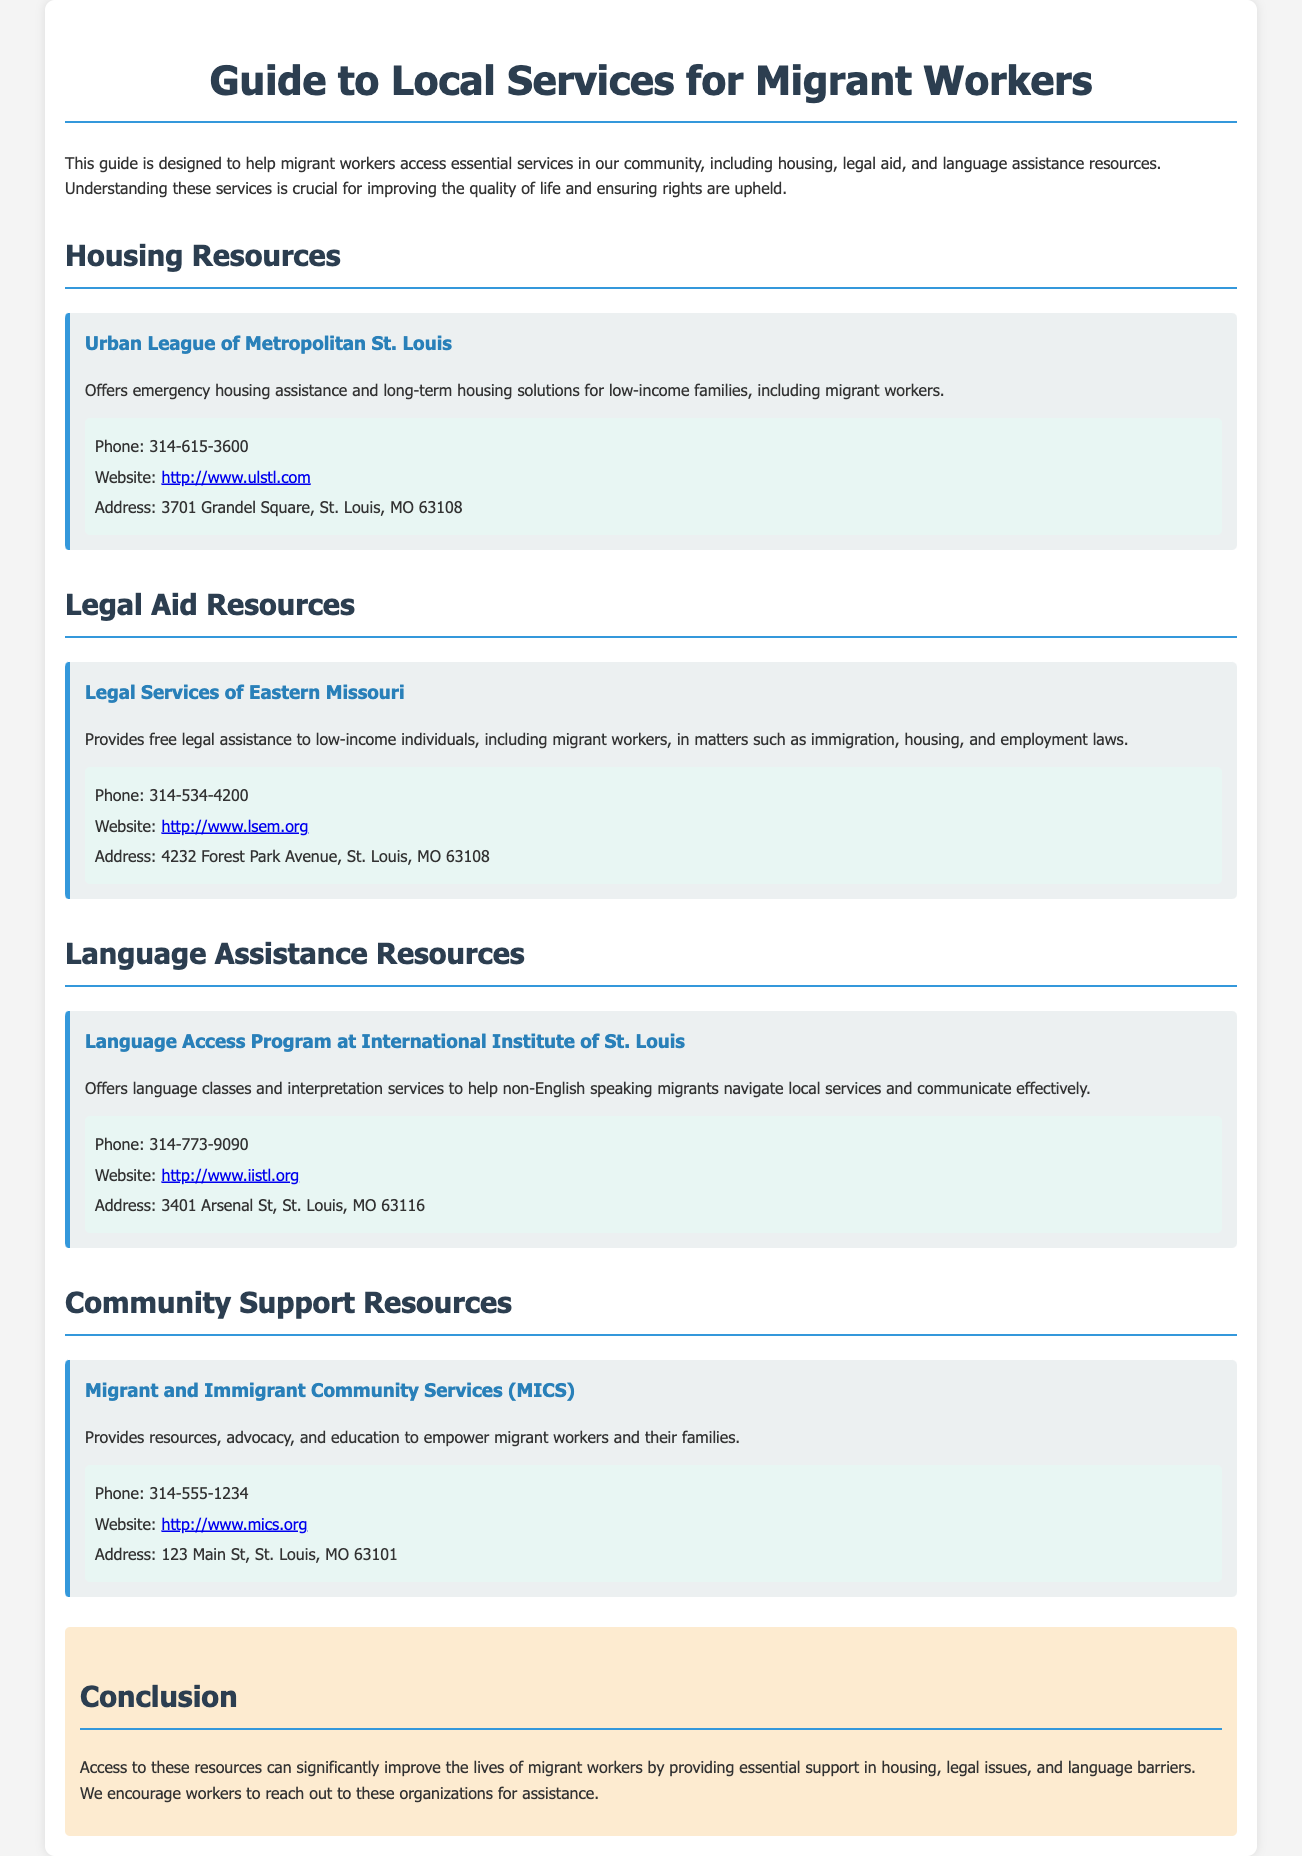What organization offers emergency housing assistance? The document lists the Urban League of Metropolitan St. Louis as providing emergency housing assistance for low-income families, including migrant workers.
Answer: Urban League of Metropolitan St. Louis What is the phone number for Legal Services of Eastern Missouri? The document provides the contact information for Legal Services of Eastern Missouri, specifically their phone number.
Answer: 314-534-4200 Which program provides language classes for migrants? The Language Access Program at the International Institute of St. Louis offers language classes to help non-English speaking migrants.
Answer: Language Access Program at International Institute of St. Louis What resources does Migrant and Immigrant Community Services provide? The document states that MICS provides resources, advocacy, and education to empower migrant workers.
Answer: Resources, advocacy, and education How many local service categories are mentioned in the document? The guide lists four categories: Housing, Legal Aid, Language Assistance, and Community Support Resources.
Answer: Four 